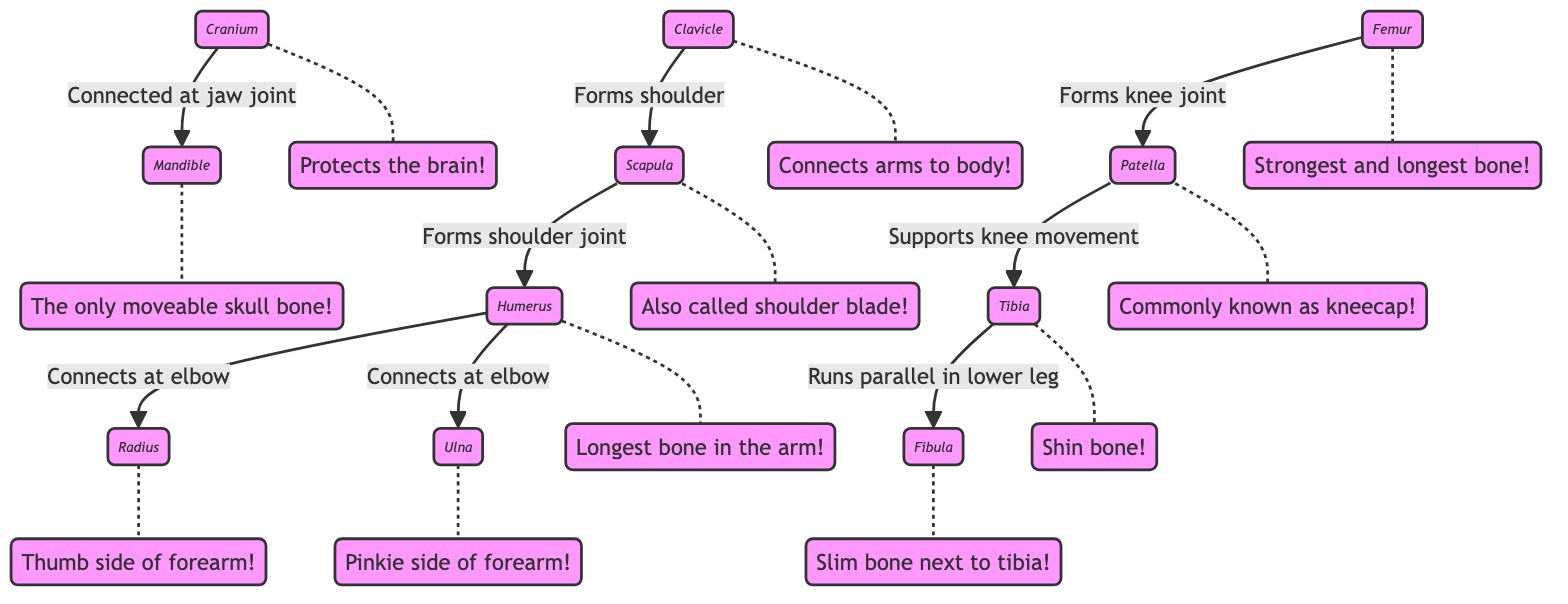What is the first bone listed in the diagram? The first bone mentioned in the diagram is labeled as "Cranium." It's the starting point of the skeletal system depicted here.
Answer: Cranium How many bones are connected to the humerus in the diagram? The humerus is connected to two bones: the radius and the ulna, at the elbow joint. So, the total is two.
Answer: 2 What part connects arms to the body? The part that connects the arms to the body is the "Clavicle," also known as the collarbone.
Answer: Clavicle Which bone is considered the longest in the arm? The longest bone in the arm is the "Humerus," as indicated in the fun facts.
Answer: Humerus What bone runs parallel to the tibia? The bone that runs parallel to the tibia is the "Fibula," according to the connections made in the diagram.
Answer: Fibula Which joint does the femur form? The femur forms the knee joint, connecting with the patella, as directly stated in the diagram's connections.
Answer: Knee joint What is the common name for the patella? The common name for the patella is "kneecap," as labeled in the fun facts section.
Answer: Kneecap How many bones are in the diagram? There are a total of 11 distinct bones represented in the diagram.
Answer: 11 Which bone is described as the only moveable skull bone? The bone described as the only moveable skull bone is the "Mandible," as shown in its fun fact.
Answer: Mandible 